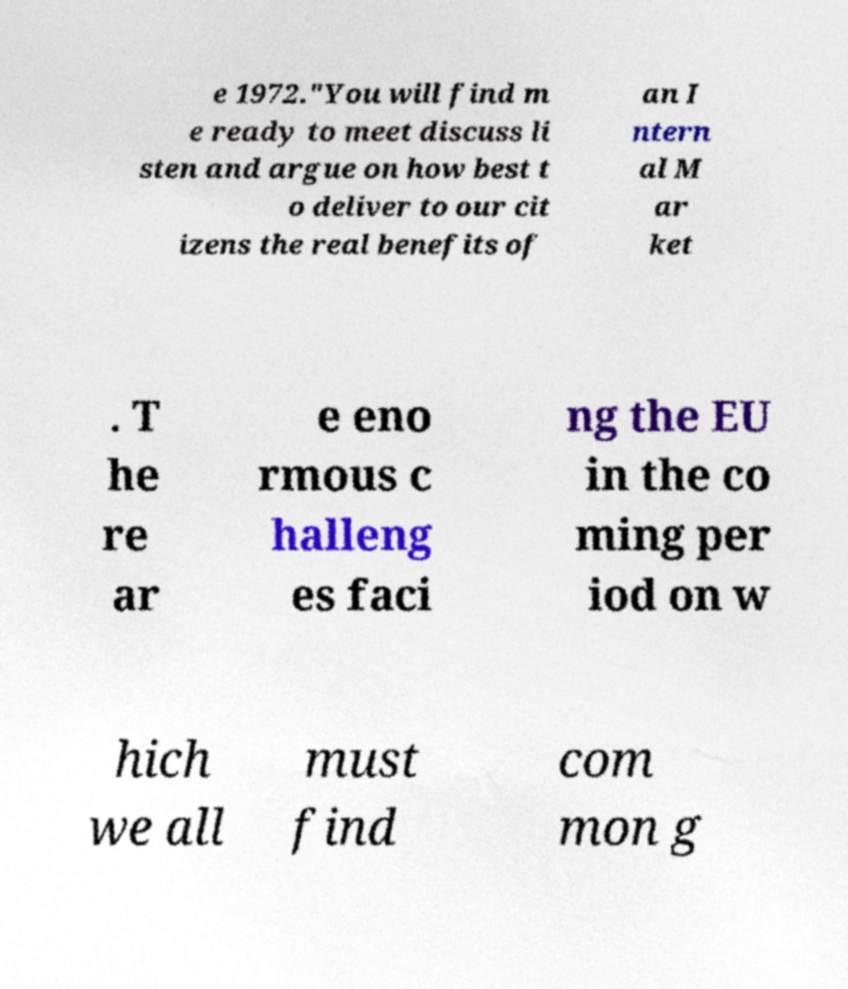Can you read and provide the text displayed in the image?This photo seems to have some interesting text. Can you extract and type it out for me? e 1972."You will find m e ready to meet discuss li sten and argue on how best t o deliver to our cit izens the real benefits of an I ntern al M ar ket . T he re ar e eno rmous c halleng es faci ng the EU in the co ming per iod on w hich we all must find com mon g 